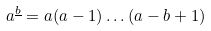Convert formula to latex. <formula><loc_0><loc_0><loc_500><loc_500>a ^ { \underline { b } } = a ( a - 1 ) \dots ( a - b + 1 )</formula> 